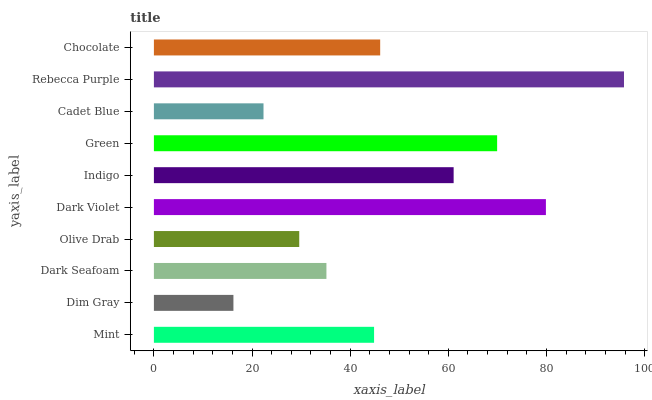Is Dim Gray the minimum?
Answer yes or no. Yes. Is Rebecca Purple the maximum?
Answer yes or no. Yes. Is Dark Seafoam the minimum?
Answer yes or no. No. Is Dark Seafoam the maximum?
Answer yes or no. No. Is Dark Seafoam greater than Dim Gray?
Answer yes or no. Yes. Is Dim Gray less than Dark Seafoam?
Answer yes or no. Yes. Is Dim Gray greater than Dark Seafoam?
Answer yes or no. No. Is Dark Seafoam less than Dim Gray?
Answer yes or no. No. Is Chocolate the high median?
Answer yes or no. Yes. Is Mint the low median?
Answer yes or no. Yes. Is Dim Gray the high median?
Answer yes or no. No. Is Indigo the low median?
Answer yes or no. No. 